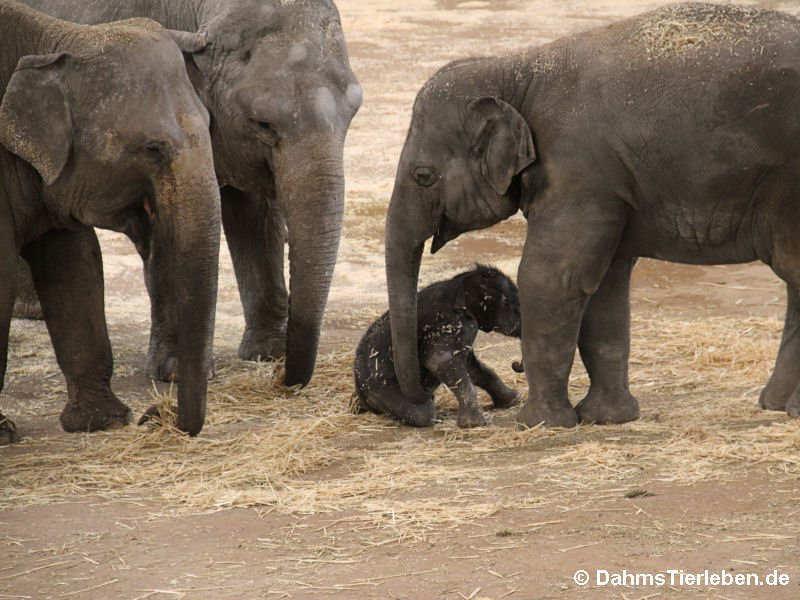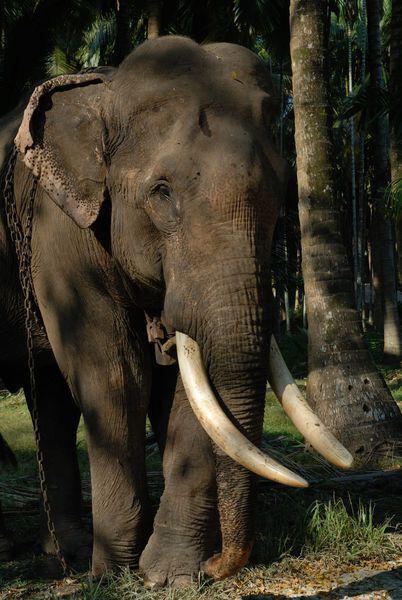The first image is the image on the left, the second image is the image on the right. Given the left and right images, does the statement "Right image shows a forward facing baby elephant to the right of an adult elephant's legs." hold true? Answer yes or no. No. The first image is the image on the left, the second image is the image on the right. For the images shown, is this caption "All images show at least one young elephant." true? Answer yes or no. No. 